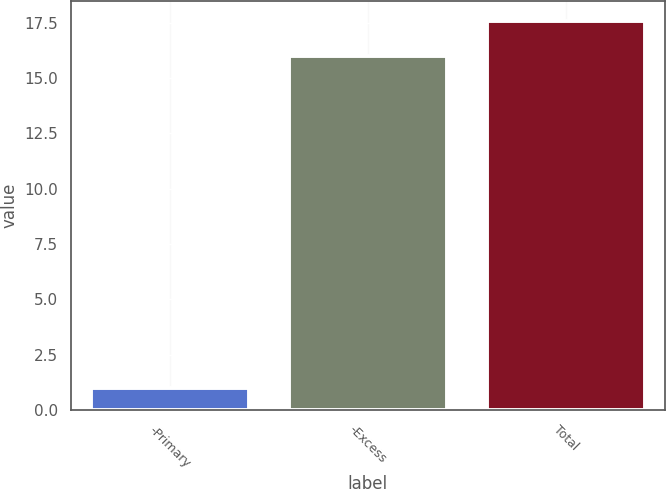Convert chart to OTSL. <chart><loc_0><loc_0><loc_500><loc_500><bar_chart><fcel>-Primary<fcel>-Excess<fcel>Total<nl><fcel>1<fcel>16<fcel>17.6<nl></chart> 